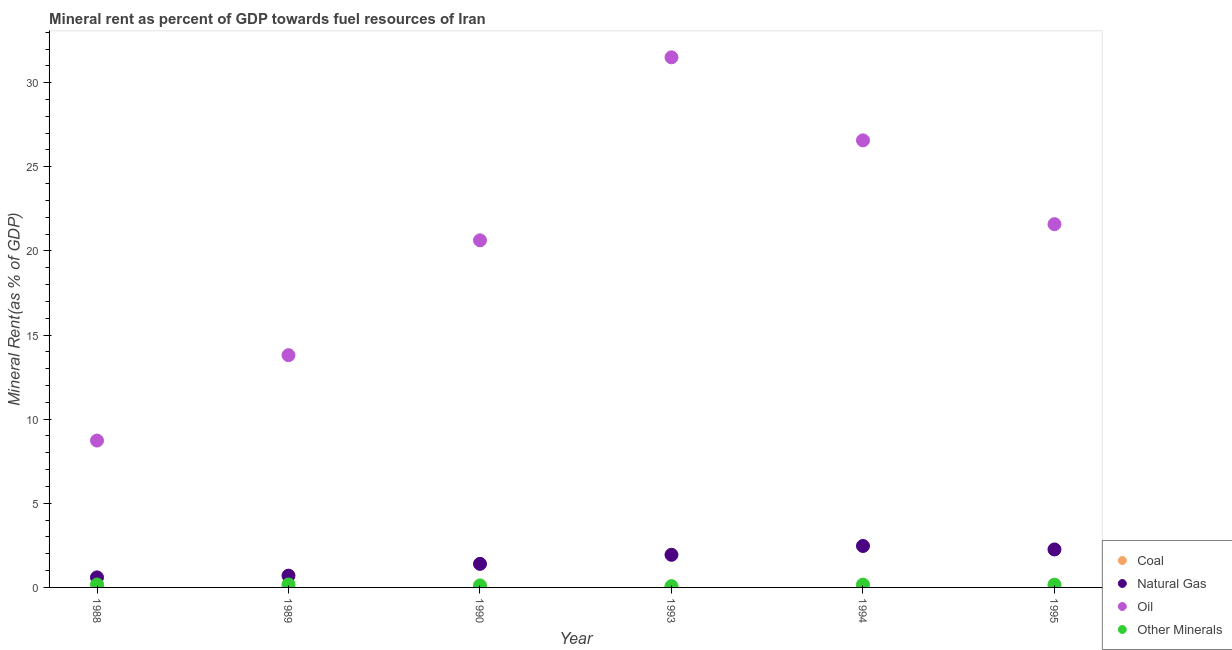How many different coloured dotlines are there?
Your answer should be very brief. 4. What is the coal rent in 1989?
Provide a succinct answer. 0.01. Across all years, what is the maximum coal rent?
Your answer should be compact. 0.01. Across all years, what is the minimum  rent of other minerals?
Your answer should be very brief. 0.08. In which year was the oil rent maximum?
Your response must be concise. 1993. What is the total  rent of other minerals in the graph?
Your response must be concise. 0.88. What is the difference between the oil rent in 1989 and that in 1995?
Your response must be concise. -7.79. What is the difference between the natural gas rent in 1994 and the oil rent in 1988?
Give a very brief answer. -6.27. What is the average natural gas rent per year?
Provide a short and direct response. 1.56. In the year 1995, what is the difference between the natural gas rent and coal rent?
Your response must be concise. 2.25. What is the ratio of the natural gas rent in 1988 to that in 1994?
Provide a succinct answer. 0.24. Is the difference between the natural gas rent in 1989 and 1993 greater than the difference between the oil rent in 1989 and 1993?
Your answer should be compact. Yes. What is the difference between the highest and the second highest  rent of other minerals?
Give a very brief answer. 0. What is the difference between the highest and the lowest  rent of other minerals?
Your answer should be compact. 0.1. Is the sum of the oil rent in 1988 and 1993 greater than the maximum  rent of other minerals across all years?
Keep it short and to the point. Yes. Does the coal rent monotonically increase over the years?
Provide a succinct answer. No. Is the oil rent strictly greater than the  rent of other minerals over the years?
Your response must be concise. Yes. Is the coal rent strictly less than the natural gas rent over the years?
Keep it short and to the point. Yes. What is the difference between two consecutive major ticks on the Y-axis?
Offer a terse response. 5. Are the values on the major ticks of Y-axis written in scientific E-notation?
Keep it short and to the point. No. Does the graph contain any zero values?
Your response must be concise. No. Does the graph contain grids?
Offer a very short reply. No. How are the legend labels stacked?
Give a very brief answer. Vertical. What is the title of the graph?
Offer a very short reply. Mineral rent as percent of GDP towards fuel resources of Iran. What is the label or title of the X-axis?
Keep it short and to the point. Year. What is the label or title of the Y-axis?
Offer a terse response. Mineral Rent(as % of GDP). What is the Mineral Rent(as % of GDP) of Coal in 1988?
Provide a short and direct response. 0.01. What is the Mineral Rent(as % of GDP) in Natural Gas in 1988?
Provide a succinct answer. 0.6. What is the Mineral Rent(as % of GDP) of Oil in 1988?
Offer a terse response. 8.73. What is the Mineral Rent(as % of GDP) in Other Minerals in 1988?
Make the answer very short. 0.17. What is the Mineral Rent(as % of GDP) of Coal in 1989?
Offer a very short reply. 0.01. What is the Mineral Rent(as % of GDP) in Natural Gas in 1989?
Offer a very short reply. 0.7. What is the Mineral Rent(as % of GDP) in Oil in 1989?
Ensure brevity in your answer.  13.8. What is the Mineral Rent(as % of GDP) of Other Minerals in 1989?
Your response must be concise. 0.18. What is the Mineral Rent(as % of GDP) of Coal in 1990?
Your answer should be very brief. 0.01. What is the Mineral Rent(as % of GDP) of Natural Gas in 1990?
Ensure brevity in your answer.  1.4. What is the Mineral Rent(as % of GDP) of Oil in 1990?
Give a very brief answer. 20.63. What is the Mineral Rent(as % of GDP) in Other Minerals in 1990?
Your answer should be very brief. 0.12. What is the Mineral Rent(as % of GDP) in Coal in 1993?
Your response must be concise. 0.01. What is the Mineral Rent(as % of GDP) in Natural Gas in 1993?
Keep it short and to the point. 1.94. What is the Mineral Rent(as % of GDP) of Oil in 1993?
Give a very brief answer. 31.51. What is the Mineral Rent(as % of GDP) in Other Minerals in 1993?
Offer a terse response. 0.08. What is the Mineral Rent(as % of GDP) of Coal in 1994?
Provide a succinct answer. 0.01. What is the Mineral Rent(as % of GDP) of Natural Gas in 1994?
Your answer should be very brief. 2.46. What is the Mineral Rent(as % of GDP) in Oil in 1994?
Your answer should be compact. 26.57. What is the Mineral Rent(as % of GDP) in Other Minerals in 1994?
Ensure brevity in your answer.  0.17. What is the Mineral Rent(as % of GDP) of Coal in 1995?
Your answer should be very brief. 0.01. What is the Mineral Rent(as % of GDP) of Natural Gas in 1995?
Your answer should be compact. 2.26. What is the Mineral Rent(as % of GDP) of Oil in 1995?
Ensure brevity in your answer.  21.59. What is the Mineral Rent(as % of GDP) of Other Minerals in 1995?
Offer a terse response. 0.16. Across all years, what is the maximum Mineral Rent(as % of GDP) of Coal?
Provide a short and direct response. 0.01. Across all years, what is the maximum Mineral Rent(as % of GDP) of Natural Gas?
Provide a short and direct response. 2.46. Across all years, what is the maximum Mineral Rent(as % of GDP) in Oil?
Provide a succinct answer. 31.51. Across all years, what is the maximum Mineral Rent(as % of GDP) of Other Minerals?
Your response must be concise. 0.18. Across all years, what is the minimum Mineral Rent(as % of GDP) in Coal?
Offer a terse response. 0.01. Across all years, what is the minimum Mineral Rent(as % of GDP) in Natural Gas?
Your answer should be very brief. 0.6. Across all years, what is the minimum Mineral Rent(as % of GDP) in Oil?
Provide a short and direct response. 8.73. Across all years, what is the minimum Mineral Rent(as % of GDP) of Other Minerals?
Your response must be concise. 0.08. What is the total Mineral Rent(as % of GDP) in Coal in the graph?
Your answer should be very brief. 0.05. What is the total Mineral Rent(as % of GDP) in Natural Gas in the graph?
Make the answer very short. 9.36. What is the total Mineral Rent(as % of GDP) in Oil in the graph?
Your response must be concise. 122.83. What is the total Mineral Rent(as % of GDP) of Other Minerals in the graph?
Offer a terse response. 0.88. What is the difference between the Mineral Rent(as % of GDP) of Coal in 1988 and that in 1989?
Give a very brief answer. -0. What is the difference between the Mineral Rent(as % of GDP) in Natural Gas in 1988 and that in 1989?
Provide a succinct answer. -0.1. What is the difference between the Mineral Rent(as % of GDP) of Oil in 1988 and that in 1989?
Provide a short and direct response. -5.07. What is the difference between the Mineral Rent(as % of GDP) in Other Minerals in 1988 and that in 1989?
Ensure brevity in your answer.  -0. What is the difference between the Mineral Rent(as % of GDP) in Coal in 1988 and that in 1990?
Offer a very short reply. -0. What is the difference between the Mineral Rent(as % of GDP) in Natural Gas in 1988 and that in 1990?
Offer a terse response. -0.8. What is the difference between the Mineral Rent(as % of GDP) of Oil in 1988 and that in 1990?
Ensure brevity in your answer.  -11.9. What is the difference between the Mineral Rent(as % of GDP) of Other Minerals in 1988 and that in 1990?
Your answer should be compact. 0.06. What is the difference between the Mineral Rent(as % of GDP) in Coal in 1988 and that in 1993?
Give a very brief answer. 0. What is the difference between the Mineral Rent(as % of GDP) in Natural Gas in 1988 and that in 1993?
Offer a terse response. -1.34. What is the difference between the Mineral Rent(as % of GDP) in Oil in 1988 and that in 1993?
Your answer should be very brief. -22.78. What is the difference between the Mineral Rent(as % of GDP) in Other Minerals in 1988 and that in 1993?
Offer a terse response. 0.1. What is the difference between the Mineral Rent(as % of GDP) of Coal in 1988 and that in 1994?
Make the answer very short. -0. What is the difference between the Mineral Rent(as % of GDP) in Natural Gas in 1988 and that in 1994?
Provide a short and direct response. -1.87. What is the difference between the Mineral Rent(as % of GDP) of Oil in 1988 and that in 1994?
Provide a succinct answer. -17.84. What is the difference between the Mineral Rent(as % of GDP) in Other Minerals in 1988 and that in 1994?
Ensure brevity in your answer.  0.01. What is the difference between the Mineral Rent(as % of GDP) of Coal in 1988 and that in 1995?
Provide a succinct answer. -0. What is the difference between the Mineral Rent(as % of GDP) in Natural Gas in 1988 and that in 1995?
Your response must be concise. -1.66. What is the difference between the Mineral Rent(as % of GDP) of Oil in 1988 and that in 1995?
Your answer should be compact. -12.86. What is the difference between the Mineral Rent(as % of GDP) of Other Minerals in 1988 and that in 1995?
Your response must be concise. 0.01. What is the difference between the Mineral Rent(as % of GDP) in Coal in 1989 and that in 1990?
Make the answer very short. -0. What is the difference between the Mineral Rent(as % of GDP) in Natural Gas in 1989 and that in 1990?
Make the answer very short. -0.7. What is the difference between the Mineral Rent(as % of GDP) of Oil in 1989 and that in 1990?
Make the answer very short. -6.83. What is the difference between the Mineral Rent(as % of GDP) of Other Minerals in 1989 and that in 1990?
Keep it short and to the point. 0.06. What is the difference between the Mineral Rent(as % of GDP) of Coal in 1989 and that in 1993?
Your answer should be very brief. 0. What is the difference between the Mineral Rent(as % of GDP) in Natural Gas in 1989 and that in 1993?
Your answer should be compact. -1.24. What is the difference between the Mineral Rent(as % of GDP) in Oil in 1989 and that in 1993?
Offer a very short reply. -17.7. What is the difference between the Mineral Rent(as % of GDP) in Other Minerals in 1989 and that in 1993?
Offer a very short reply. 0.1. What is the difference between the Mineral Rent(as % of GDP) in Coal in 1989 and that in 1994?
Provide a short and direct response. -0. What is the difference between the Mineral Rent(as % of GDP) in Natural Gas in 1989 and that in 1994?
Your answer should be compact. -1.76. What is the difference between the Mineral Rent(as % of GDP) in Oil in 1989 and that in 1994?
Offer a terse response. -12.77. What is the difference between the Mineral Rent(as % of GDP) in Other Minerals in 1989 and that in 1994?
Your response must be concise. 0.01. What is the difference between the Mineral Rent(as % of GDP) of Coal in 1989 and that in 1995?
Keep it short and to the point. -0. What is the difference between the Mineral Rent(as % of GDP) of Natural Gas in 1989 and that in 1995?
Your answer should be compact. -1.56. What is the difference between the Mineral Rent(as % of GDP) in Oil in 1989 and that in 1995?
Keep it short and to the point. -7.79. What is the difference between the Mineral Rent(as % of GDP) of Other Minerals in 1989 and that in 1995?
Give a very brief answer. 0.01. What is the difference between the Mineral Rent(as % of GDP) of Coal in 1990 and that in 1993?
Your answer should be very brief. 0. What is the difference between the Mineral Rent(as % of GDP) in Natural Gas in 1990 and that in 1993?
Keep it short and to the point. -0.54. What is the difference between the Mineral Rent(as % of GDP) in Oil in 1990 and that in 1993?
Offer a terse response. -10.88. What is the difference between the Mineral Rent(as % of GDP) of Other Minerals in 1990 and that in 1993?
Offer a very short reply. 0.04. What is the difference between the Mineral Rent(as % of GDP) of Coal in 1990 and that in 1994?
Keep it short and to the point. -0. What is the difference between the Mineral Rent(as % of GDP) in Natural Gas in 1990 and that in 1994?
Your response must be concise. -1.06. What is the difference between the Mineral Rent(as % of GDP) in Oil in 1990 and that in 1994?
Ensure brevity in your answer.  -5.94. What is the difference between the Mineral Rent(as % of GDP) of Other Minerals in 1990 and that in 1994?
Keep it short and to the point. -0.05. What is the difference between the Mineral Rent(as % of GDP) in Coal in 1990 and that in 1995?
Your answer should be compact. -0. What is the difference between the Mineral Rent(as % of GDP) of Natural Gas in 1990 and that in 1995?
Provide a short and direct response. -0.86. What is the difference between the Mineral Rent(as % of GDP) in Oil in 1990 and that in 1995?
Make the answer very short. -0.96. What is the difference between the Mineral Rent(as % of GDP) of Other Minerals in 1990 and that in 1995?
Offer a very short reply. -0.05. What is the difference between the Mineral Rent(as % of GDP) of Coal in 1993 and that in 1994?
Your answer should be compact. -0. What is the difference between the Mineral Rent(as % of GDP) in Natural Gas in 1993 and that in 1994?
Provide a succinct answer. -0.52. What is the difference between the Mineral Rent(as % of GDP) in Oil in 1993 and that in 1994?
Make the answer very short. 4.94. What is the difference between the Mineral Rent(as % of GDP) of Other Minerals in 1993 and that in 1994?
Your response must be concise. -0.09. What is the difference between the Mineral Rent(as % of GDP) in Coal in 1993 and that in 1995?
Make the answer very short. -0.01. What is the difference between the Mineral Rent(as % of GDP) of Natural Gas in 1993 and that in 1995?
Offer a terse response. -0.32. What is the difference between the Mineral Rent(as % of GDP) in Oil in 1993 and that in 1995?
Provide a succinct answer. 9.92. What is the difference between the Mineral Rent(as % of GDP) of Other Minerals in 1993 and that in 1995?
Offer a very short reply. -0.09. What is the difference between the Mineral Rent(as % of GDP) in Coal in 1994 and that in 1995?
Give a very brief answer. -0. What is the difference between the Mineral Rent(as % of GDP) of Natural Gas in 1994 and that in 1995?
Your answer should be very brief. 0.21. What is the difference between the Mineral Rent(as % of GDP) of Oil in 1994 and that in 1995?
Ensure brevity in your answer.  4.98. What is the difference between the Mineral Rent(as % of GDP) in Other Minerals in 1994 and that in 1995?
Offer a terse response. 0. What is the difference between the Mineral Rent(as % of GDP) in Coal in 1988 and the Mineral Rent(as % of GDP) in Natural Gas in 1989?
Give a very brief answer. -0.69. What is the difference between the Mineral Rent(as % of GDP) in Coal in 1988 and the Mineral Rent(as % of GDP) in Oil in 1989?
Your answer should be compact. -13.8. What is the difference between the Mineral Rent(as % of GDP) of Coal in 1988 and the Mineral Rent(as % of GDP) of Other Minerals in 1989?
Make the answer very short. -0.17. What is the difference between the Mineral Rent(as % of GDP) of Natural Gas in 1988 and the Mineral Rent(as % of GDP) of Oil in 1989?
Offer a very short reply. -13.21. What is the difference between the Mineral Rent(as % of GDP) of Natural Gas in 1988 and the Mineral Rent(as % of GDP) of Other Minerals in 1989?
Provide a succinct answer. 0.42. What is the difference between the Mineral Rent(as % of GDP) in Oil in 1988 and the Mineral Rent(as % of GDP) in Other Minerals in 1989?
Your answer should be very brief. 8.55. What is the difference between the Mineral Rent(as % of GDP) in Coal in 1988 and the Mineral Rent(as % of GDP) in Natural Gas in 1990?
Your answer should be very brief. -1.39. What is the difference between the Mineral Rent(as % of GDP) in Coal in 1988 and the Mineral Rent(as % of GDP) in Oil in 1990?
Keep it short and to the point. -20.62. What is the difference between the Mineral Rent(as % of GDP) in Coal in 1988 and the Mineral Rent(as % of GDP) in Other Minerals in 1990?
Ensure brevity in your answer.  -0.11. What is the difference between the Mineral Rent(as % of GDP) of Natural Gas in 1988 and the Mineral Rent(as % of GDP) of Oil in 1990?
Your answer should be very brief. -20.03. What is the difference between the Mineral Rent(as % of GDP) in Natural Gas in 1988 and the Mineral Rent(as % of GDP) in Other Minerals in 1990?
Your answer should be very brief. 0.48. What is the difference between the Mineral Rent(as % of GDP) of Oil in 1988 and the Mineral Rent(as % of GDP) of Other Minerals in 1990?
Provide a short and direct response. 8.61. What is the difference between the Mineral Rent(as % of GDP) of Coal in 1988 and the Mineral Rent(as % of GDP) of Natural Gas in 1993?
Give a very brief answer. -1.93. What is the difference between the Mineral Rent(as % of GDP) in Coal in 1988 and the Mineral Rent(as % of GDP) in Oil in 1993?
Provide a short and direct response. -31.5. What is the difference between the Mineral Rent(as % of GDP) in Coal in 1988 and the Mineral Rent(as % of GDP) in Other Minerals in 1993?
Offer a very short reply. -0.07. What is the difference between the Mineral Rent(as % of GDP) of Natural Gas in 1988 and the Mineral Rent(as % of GDP) of Oil in 1993?
Your answer should be compact. -30.91. What is the difference between the Mineral Rent(as % of GDP) of Natural Gas in 1988 and the Mineral Rent(as % of GDP) of Other Minerals in 1993?
Provide a short and direct response. 0.52. What is the difference between the Mineral Rent(as % of GDP) of Oil in 1988 and the Mineral Rent(as % of GDP) of Other Minerals in 1993?
Offer a terse response. 8.65. What is the difference between the Mineral Rent(as % of GDP) of Coal in 1988 and the Mineral Rent(as % of GDP) of Natural Gas in 1994?
Provide a short and direct response. -2.46. What is the difference between the Mineral Rent(as % of GDP) in Coal in 1988 and the Mineral Rent(as % of GDP) in Oil in 1994?
Keep it short and to the point. -26.56. What is the difference between the Mineral Rent(as % of GDP) in Coal in 1988 and the Mineral Rent(as % of GDP) in Other Minerals in 1994?
Your answer should be compact. -0.16. What is the difference between the Mineral Rent(as % of GDP) of Natural Gas in 1988 and the Mineral Rent(as % of GDP) of Oil in 1994?
Give a very brief answer. -25.97. What is the difference between the Mineral Rent(as % of GDP) in Natural Gas in 1988 and the Mineral Rent(as % of GDP) in Other Minerals in 1994?
Provide a short and direct response. 0.43. What is the difference between the Mineral Rent(as % of GDP) of Oil in 1988 and the Mineral Rent(as % of GDP) of Other Minerals in 1994?
Your answer should be very brief. 8.56. What is the difference between the Mineral Rent(as % of GDP) in Coal in 1988 and the Mineral Rent(as % of GDP) in Natural Gas in 1995?
Your response must be concise. -2.25. What is the difference between the Mineral Rent(as % of GDP) of Coal in 1988 and the Mineral Rent(as % of GDP) of Oil in 1995?
Your answer should be compact. -21.58. What is the difference between the Mineral Rent(as % of GDP) in Coal in 1988 and the Mineral Rent(as % of GDP) in Other Minerals in 1995?
Give a very brief answer. -0.16. What is the difference between the Mineral Rent(as % of GDP) in Natural Gas in 1988 and the Mineral Rent(as % of GDP) in Oil in 1995?
Your answer should be compact. -20.99. What is the difference between the Mineral Rent(as % of GDP) of Natural Gas in 1988 and the Mineral Rent(as % of GDP) of Other Minerals in 1995?
Provide a succinct answer. 0.43. What is the difference between the Mineral Rent(as % of GDP) of Oil in 1988 and the Mineral Rent(as % of GDP) of Other Minerals in 1995?
Your response must be concise. 8.57. What is the difference between the Mineral Rent(as % of GDP) in Coal in 1989 and the Mineral Rent(as % of GDP) in Natural Gas in 1990?
Make the answer very short. -1.39. What is the difference between the Mineral Rent(as % of GDP) of Coal in 1989 and the Mineral Rent(as % of GDP) of Oil in 1990?
Offer a very short reply. -20.62. What is the difference between the Mineral Rent(as % of GDP) of Coal in 1989 and the Mineral Rent(as % of GDP) of Other Minerals in 1990?
Your answer should be very brief. -0.11. What is the difference between the Mineral Rent(as % of GDP) in Natural Gas in 1989 and the Mineral Rent(as % of GDP) in Oil in 1990?
Your answer should be very brief. -19.93. What is the difference between the Mineral Rent(as % of GDP) in Natural Gas in 1989 and the Mineral Rent(as % of GDP) in Other Minerals in 1990?
Your answer should be very brief. 0.58. What is the difference between the Mineral Rent(as % of GDP) of Oil in 1989 and the Mineral Rent(as % of GDP) of Other Minerals in 1990?
Your answer should be very brief. 13.69. What is the difference between the Mineral Rent(as % of GDP) of Coal in 1989 and the Mineral Rent(as % of GDP) of Natural Gas in 1993?
Offer a very short reply. -1.93. What is the difference between the Mineral Rent(as % of GDP) in Coal in 1989 and the Mineral Rent(as % of GDP) in Oil in 1993?
Your response must be concise. -31.5. What is the difference between the Mineral Rent(as % of GDP) in Coal in 1989 and the Mineral Rent(as % of GDP) in Other Minerals in 1993?
Keep it short and to the point. -0.07. What is the difference between the Mineral Rent(as % of GDP) of Natural Gas in 1989 and the Mineral Rent(as % of GDP) of Oil in 1993?
Make the answer very short. -30.81. What is the difference between the Mineral Rent(as % of GDP) in Natural Gas in 1989 and the Mineral Rent(as % of GDP) in Other Minerals in 1993?
Keep it short and to the point. 0.62. What is the difference between the Mineral Rent(as % of GDP) of Oil in 1989 and the Mineral Rent(as % of GDP) of Other Minerals in 1993?
Keep it short and to the point. 13.73. What is the difference between the Mineral Rent(as % of GDP) of Coal in 1989 and the Mineral Rent(as % of GDP) of Natural Gas in 1994?
Give a very brief answer. -2.46. What is the difference between the Mineral Rent(as % of GDP) of Coal in 1989 and the Mineral Rent(as % of GDP) of Oil in 1994?
Offer a very short reply. -26.56. What is the difference between the Mineral Rent(as % of GDP) in Coal in 1989 and the Mineral Rent(as % of GDP) in Other Minerals in 1994?
Your answer should be very brief. -0.16. What is the difference between the Mineral Rent(as % of GDP) in Natural Gas in 1989 and the Mineral Rent(as % of GDP) in Oil in 1994?
Your response must be concise. -25.87. What is the difference between the Mineral Rent(as % of GDP) of Natural Gas in 1989 and the Mineral Rent(as % of GDP) of Other Minerals in 1994?
Provide a succinct answer. 0.53. What is the difference between the Mineral Rent(as % of GDP) of Oil in 1989 and the Mineral Rent(as % of GDP) of Other Minerals in 1994?
Offer a terse response. 13.64. What is the difference between the Mineral Rent(as % of GDP) of Coal in 1989 and the Mineral Rent(as % of GDP) of Natural Gas in 1995?
Make the answer very short. -2.25. What is the difference between the Mineral Rent(as % of GDP) of Coal in 1989 and the Mineral Rent(as % of GDP) of Oil in 1995?
Keep it short and to the point. -21.58. What is the difference between the Mineral Rent(as % of GDP) in Coal in 1989 and the Mineral Rent(as % of GDP) in Other Minerals in 1995?
Your answer should be compact. -0.16. What is the difference between the Mineral Rent(as % of GDP) in Natural Gas in 1989 and the Mineral Rent(as % of GDP) in Oil in 1995?
Your answer should be compact. -20.89. What is the difference between the Mineral Rent(as % of GDP) of Natural Gas in 1989 and the Mineral Rent(as % of GDP) of Other Minerals in 1995?
Your response must be concise. 0.54. What is the difference between the Mineral Rent(as % of GDP) of Oil in 1989 and the Mineral Rent(as % of GDP) of Other Minerals in 1995?
Offer a terse response. 13.64. What is the difference between the Mineral Rent(as % of GDP) of Coal in 1990 and the Mineral Rent(as % of GDP) of Natural Gas in 1993?
Your answer should be compact. -1.93. What is the difference between the Mineral Rent(as % of GDP) of Coal in 1990 and the Mineral Rent(as % of GDP) of Oil in 1993?
Keep it short and to the point. -31.5. What is the difference between the Mineral Rent(as % of GDP) in Coal in 1990 and the Mineral Rent(as % of GDP) in Other Minerals in 1993?
Your response must be concise. -0.07. What is the difference between the Mineral Rent(as % of GDP) in Natural Gas in 1990 and the Mineral Rent(as % of GDP) in Oil in 1993?
Offer a very short reply. -30.11. What is the difference between the Mineral Rent(as % of GDP) in Natural Gas in 1990 and the Mineral Rent(as % of GDP) in Other Minerals in 1993?
Offer a terse response. 1.32. What is the difference between the Mineral Rent(as % of GDP) in Oil in 1990 and the Mineral Rent(as % of GDP) in Other Minerals in 1993?
Your answer should be compact. 20.55. What is the difference between the Mineral Rent(as % of GDP) of Coal in 1990 and the Mineral Rent(as % of GDP) of Natural Gas in 1994?
Your response must be concise. -2.46. What is the difference between the Mineral Rent(as % of GDP) of Coal in 1990 and the Mineral Rent(as % of GDP) of Oil in 1994?
Make the answer very short. -26.56. What is the difference between the Mineral Rent(as % of GDP) in Coal in 1990 and the Mineral Rent(as % of GDP) in Other Minerals in 1994?
Your answer should be very brief. -0.16. What is the difference between the Mineral Rent(as % of GDP) of Natural Gas in 1990 and the Mineral Rent(as % of GDP) of Oil in 1994?
Ensure brevity in your answer.  -25.17. What is the difference between the Mineral Rent(as % of GDP) of Natural Gas in 1990 and the Mineral Rent(as % of GDP) of Other Minerals in 1994?
Make the answer very short. 1.23. What is the difference between the Mineral Rent(as % of GDP) of Oil in 1990 and the Mineral Rent(as % of GDP) of Other Minerals in 1994?
Offer a very short reply. 20.46. What is the difference between the Mineral Rent(as % of GDP) in Coal in 1990 and the Mineral Rent(as % of GDP) in Natural Gas in 1995?
Give a very brief answer. -2.25. What is the difference between the Mineral Rent(as % of GDP) of Coal in 1990 and the Mineral Rent(as % of GDP) of Oil in 1995?
Give a very brief answer. -21.58. What is the difference between the Mineral Rent(as % of GDP) in Coal in 1990 and the Mineral Rent(as % of GDP) in Other Minerals in 1995?
Provide a short and direct response. -0.16. What is the difference between the Mineral Rent(as % of GDP) of Natural Gas in 1990 and the Mineral Rent(as % of GDP) of Oil in 1995?
Offer a very short reply. -20.19. What is the difference between the Mineral Rent(as % of GDP) of Natural Gas in 1990 and the Mineral Rent(as % of GDP) of Other Minerals in 1995?
Offer a very short reply. 1.24. What is the difference between the Mineral Rent(as % of GDP) of Oil in 1990 and the Mineral Rent(as % of GDP) of Other Minerals in 1995?
Ensure brevity in your answer.  20.47. What is the difference between the Mineral Rent(as % of GDP) of Coal in 1993 and the Mineral Rent(as % of GDP) of Natural Gas in 1994?
Give a very brief answer. -2.46. What is the difference between the Mineral Rent(as % of GDP) of Coal in 1993 and the Mineral Rent(as % of GDP) of Oil in 1994?
Provide a short and direct response. -26.56. What is the difference between the Mineral Rent(as % of GDP) of Coal in 1993 and the Mineral Rent(as % of GDP) of Other Minerals in 1994?
Give a very brief answer. -0.16. What is the difference between the Mineral Rent(as % of GDP) of Natural Gas in 1993 and the Mineral Rent(as % of GDP) of Oil in 1994?
Offer a very short reply. -24.63. What is the difference between the Mineral Rent(as % of GDP) of Natural Gas in 1993 and the Mineral Rent(as % of GDP) of Other Minerals in 1994?
Offer a terse response. 1.77. What is the difference between the Mineral Rent(as % of GDP) of Oil in 1993 and the Mineral Rent(as % of GDP) of Other Minerals in 1994?
Keep it short and to the point. 31.34. What is the difference between the Mineral Rent(as % of GDP) of Coal in 1993 and the Mineral Rent(as % of GDP) of Natural Gas in 1995?
Your response must be concise. -2.25. What is the difference between the Mineral Rent(as % of GDP) of Coal in 1993 and the Mineral Rent(as % of GDP) of Oil in 1995?
Provide a short and direct response. -21.58. What is the difference between the Mineral Rent(as % of GDP) of Coal in 1993 and the Mineral Rent(as % of GDP) of Other Minerals in 1995?
Your answer should be compact. -0.16. What is the difference between the Mineral Rent(as % of GDP) of Natural Gas in 1993 and the Mineral Rent(as % of GDP) of Oil in 1995?
Give a very brief answer. -19.65. What is the difference between the Mineral Rent(as % of GDP) in Natural Gas in 1993 and the Mineral Rent(as % of GDP) in Other Minerals in 1995?
Provide a short and direct response. 1.78. What is the difference between the Mineral Rent(as % of GDP) in Oil in 1993 and the Mineral Rent(as % of GDP) in Other Minerals in 1995?
Offer a very short reply. 31.34. What is the difference between the Mineral Rent(as % of GDP) in Coal in 1994 and the Mineral Rent(as % of GDP) in Natural Gas in 1995?
Provide a short and direct response. -2.25. What is the difference between the Mineral Rent(as % of GDP) of Coal in 1994 and the Mineral Rent(as % of GDP) of Oil in 1995?
Your answer should be very brief. -21.58. What is the difference between the Mineral Rent(as % of GDP) in Coal in 1994 and the Mineral Rent(as % of GDP) in Other Minerals in 1995?
Your answer should be very brief. -0.16. What is the difference between the Mineral Rent(as % of GDP) in Natural Gas in 1994 and the Mineral Rent(as % of GDP) in Oil in 1995?
Provide a short and direct response. -19.13. What is the difference between the Mineral Rent(as % of GDP) in Natural Gas in 1994 and the Mineral Rent(as % of GDP) in Other Minerals in 1995?
Give a very brief answer. 2.3. What is the difference between the Mineral Rent(as % of GDP) of Oil in 1994 and the Mineral Rent(as % of GDP) of Other Minerals in 1995?
Provide a succinct answer. 26.41. What is the average Mineral Rent(as % of GDP) of Coal per year?
Your answer should be very brief. 0.01. What is the average Mineral Rent(as % of GDP) of Natural Gas per year?
Provide a short and direct response. 1.56. What is the average Mineral Rent(as % of GDP) of Oil per year?
Ensure brevity in your answer.  20.47. What is the average Mineral Rent(as % of GDP) in Other Minerals per year?
Offer a terse response. 0.15. In the year 1988, what is the difference between the Mineral Rent(as % of GDP) of Coal and Mineral Rent(as % of GDP) of Natural Gas?
Your answer should be compact. -0.59. In the year 1988, what is the difference between the Mineral Rent(as % of GDP) in Coal and Mineral Rent(as % of GDP) in Oil?
Provide a succinct answer. -8.72. In the year 1988, what is the difference between the Mineral Rent(as % of GDP) of Coal and Mineral Rent(as % of GDP) of Other Minerals?
Make the answer very short. -0.17. In the year 1988, what is the difference between the Mineral Rent(as % of GDP) of Natural Gas and Mineral Rent(as % of GDP) of Oil?
Your answer should be very brief. -8.13. In the year 1988, what is the difference between the Mineral Rent(as % of GDP) in Natural Gas and Mineral Rent(as % of GDP) in Other Minerals?
Your response must be concise. 0.42. In the year 1988, what is the difference between the Mineral Rent(as % of GDP) of Oil and Mineral Rent(as % of GDP) of Other Minerals?
Your answer should be compact. 8.55. In the year 1989, what is the difference between the Mineral Rent(as % of GDP) in Coal and Mineral Rent(as % of GDP) in Natural Gas?
Provide a succinct answer. -0.69. In the year 1989, what is the difference between the Mineral Rent(as % of GDP) of Coal and Mineral Rent(as % of GDP) of Oil?
Provide a succinct answer. -13.8. In the year 1989, what is the difference between the Mineral Rent(as % of GDP) of Coal and Mineral Rent(as % of GDP) of Other Minerals?
Give a very brief answer. -0.17. In the year 1989, what is the difference between the Mineral Rent(as % of GDP) in Natural Gas and Mineral Rent(as % of GDP) in Oil?
Your answer should be compact. -13.1. In the year 1989, what is the difference between the Mineral Rent(as % of GDP) in Natural Gas and Mineral Rent(as % of GDP) in Other Minerals?
Provide a short and direct response. 0.52. In the year 1989, what is the difference between the Mineral Rent(as % of GDP) in Oil and Mineral Rent(as % of GDP) in Other Minerals?
Give a very brief answer. 13.63. In the year 1990, what is the difference between the Mineral Rent(as % of GDP) of Coal and Mineral Rent(as % of GDP) of Natural Gas?
Your response must be concise. -1.39. In the year 1990, what is the difference between the Mineral Rent(as % of GDP) of Coal and Mineral Rent(as % of GDP) of Oil?
Give a very brief answer. -20.62. In the year 1990, what is the difference between the Mineral Rent(as % of GDP) of Coal and Mineral Rent(as % of GDP) of Other Minerals?
Ensure brevity in your answer.  -0.11. In the year 1990, what is the difference between the Mineral Rent(as % of GDP) of Natural Gas and Mineral Rent(as % of GDP) of Oil?
Your answer should be very brief. -19.23. In the year 1990, what is the difference between the Mineral Rent(as % of GDP) in Natural Gas and Mineral Rent(as % of GDP) in Other Minerals?
Your answer should be compact. 1.28. In the year 1990, what is the difference between the Mineral Rent(as % of GDP) in Oil and Mineral Rent(as % of GDP) in Other Minerals?
Offer a terse response. 20.51. In the year 1993, what is the difference between the Mineral Rent(as % of GDP) of Coal and Mineral Rent(as % of GDP) of Natural Gas?
Offer a very short reply. -1.93. In the year 1993, what is the difference between the Mineral Rent(as % of GDP) in Coal and Mineral Rent(as % of GDP) in Oil?
Make the answer very short. -31.5. In the year 1993, what is the difference between the Mineral Rent(as % of GDP) of Coal and Mineral Rent(as % of GDP) of Other Minerals?
Offer a very short reply. -0.07. In the year 1993, what is the difference between the Mineral Rent(as % of GDP) of Natural Gas and Mineral Rent(as % of GDP) of Oil?
Give a very brief answer. -29.57. In the year 1993, what is the difference between the Mineral Rent(as % of GDP) in Natural Gas and Mineral Rent(as % of GDP) in Other Minerals?
Your answer should be compact. 1.86. In the year 1993, what is the difference between the Mineral Rent(as % of GDP) in Oil and Mineral Rent(as % of GDP) in Other Minerals?
Ensure brevity in your answer.  31.43. In the year 1994, what is the difference between the Mineral Rent(as % of GDP) of Coal and Mineral Rent(as % of GDP) of Natural Gas?
Give a very brief answer. -2.46. In the year 1994, what is the difference between the Mineral Rent(as % of GDP) in Coal and Mineral Rent(as % of GDP) in Oil?
Ensure brevity in your answer.  -26.56. In the year 1994, what is the difference between the Mineral Rent(as % of GDP) in Coal and Mineral Rent(as % of GDP) in Other Minerals?
Your answer should be very brief. -0.16. In the year 1994, what is the difference between the Mineral Rent(as % of GDP) of Natural Gas and Mineral Rent(as % of GDP) of Oil?
Provide a short and direct response. -24.11. In the year 1994, what is the difference between the Mineral Rent(as % of GDP) in Natural Gas and Mineral Rent(as % of GDP) in Other Minerals?
Your response must be concise. 2.29. In the year 1994, what is the difference between the Mineral Rent(as % of GDP) in Oil and Mineral Rent(as % of GDP) in Other Minerals?
Offer a terse response. 26.4. In the year 1995, what is the difference between the Mineral Rent(as % of GDP) in Coal and Mineral Rent(as % of GDP) in Natural Gas?
Give a very brief answer. -2.25. In the year 1995, what is the difference between the Mineral Rent(as % of GDP) in Coal and Mineral Rent(as % of GDP) in Oil?
Provide a succinct answer. -21.58. In the year 1995, what is the difference between the Mineral Rent(as % of GDP) of Coal and Mineral Rent(as % of GDP) of Other Minerals?
Offer a terse response. -0.15. In the year 1995, what is the difference between the Mineral Rent(as % of GDP) of Natural Gas and Mineral Rent(as % of GDP) of Oil?
Offer a terse response. -19.33. In the year 1995, what is the difference between the Mineral Rent(as % of GDP) in Natural Gas and Mineral Rent(as % of GDP) in Other Minerals?
Your response must be concise. 2.09. In the year 1995, what is the difference between the Mineral Rent(as % of GDP) in Oil and Mineral Rent(as % of GDP) in Other Minerals?
Give a very brief answer. 21.43. What is the ratio of the Mineral Rent(as % of GDP) in Coal in 1988 to that in 1989?
Your answer should be very brief. 0.9. What is the ratio of the Mineral Rent(as % of GDP) in Natural Gas in 1988 to that in 1989?
Provide a succinct answer. 0.85. What is the ratio of the Mineral Rent(as % of GDP) of Oil in 1988 to that in 1989?
Your answer should be very brief. 0.63. What is the ratio of the Mineral Rent(as % of GDP) in Coal in 1988 to that in 1990?
Provide a succinct answer. 0.87. What is the ratio of the Mineral Rent(as % of GDP) in Natural Gas in 1988 to that in 1990?
Make the answer very short. 0.43. What is the ratio of the Mineral Rent(as % of GDP) in Oil in 1988 to that in 1990?
Provide a short and direct response. 0.42. What is the ratio of the Mineral Rent(as % of GDP) of Other Minerals in 1988 to that in 1990?
Your answer should be compact. 1.47. What is the ratio of the Mineral Rent(as % of GDP) in Coal in 1988 to that in 1993?
Give a very brief answer. 1.36. What is the ratio of the Mineral Rent(as % of GDP) in Natural Gas in 1988 to that in 1993?
Your answer should be very brief. 0.31. What is the ratio of the Mineral Rent(as % of GDP) in Oil in 1988 to that in 1993?
Ensure brevity in your answer.  0.28. What is the ratio of the Mineral Rent(as % of GDP) of Other Minerals in 1988 to that in 1993?
Your response must be concise. 2.28. What is the ratio of the Mineral Rent(as % of GDP) of Coal in 1988 to that in 1994?
Offer a terse response. 0.87. What is the ratio of the Mineral Rent(as % of GDP) in Natural Gas in 1988 to that in 1994?
Offer a very short reply. 0.24. What is the ratio of the Mineral Rent(as % of GDP) in Oil in 1988 to that in 1994?
Make the answer very short. 0.33. What is the ratio of the Mineral Rent(as % of GDP) of Other Minerals in 1988 to that in 1994?
Make the answer very short. 1.04. What is the ratio of the Mineral Rent(as % of GDP) of Coal in 1988 to that in 1995?
Make the answer very short. 0.63. What is the ratio of the Mineral Rent(as % of GDP) of Natural Gas in 1988 to that in 1995?
Keep it short and to the point. 0.26. What is the ratio of the Mineral Rent(as % of GDP) of Oil in 1988 to that in 1995?
Your answer should be very brief. 0.4. What is the ratio of the Mineral Rent(as % of GDP) of Other Minerals in 1988 to that in 1995?
Keep it short and to the point. 1.07. What is the ratio of the Mineral Rent(as % of GDP) of Coal in 1989 to that in 1990?
Your response must be concise. 0.97. What is the ratio of the Mineral Rent(as % of GDP) in Natural Gas in 1989 to that in 1990?
Offer a very short reply. 0.5. What is the ratio of the Mineral Rent(as % of GDP) of Oil in 1989 to that in 1990?
Provide a short and direct response. 0.67. What is the ratio of the Mineral Rent(as % of GDP) of Other Minerals in 1989 to that in 1990?
Keep it short and to the point. 1.48. What is the ratio of the Mineral Rent(as % of GDP) of Coal in 1989 to that in 1993?
Keep it short and to the point. 1.51. What is the ratio of the Mineral Rent(as % of GDP) in Natural Gas in 1989 to that in 1993?
Give a very brief answer. 0.36. What is the ratio of the Mineral Rent(as % of GDP) of Oil in 1989 to that in 1993?
Provide a short and direct response. 0.44. What is the ratio of the Mineral Rent(as % of GDP) in Other Minerals in 1989 to that in 1993?
Your answer should be compact. 2.3. What is the ratio of the Mineral Rent(as % of GDP) in Coal in 1989 to that in 1994?
Offer a terse response. 0.96. What is the ratio of the Mineral Rent(as % of GDP) of Natural Gas in 1989 to that in 1994?
Your answer should be compact. 0.28. What is the ratio of the Mineral Rent(as % of GDP) of Oil in 1989 to that in 1994?
Provide a succinct answer. 0.52. What is the ratio of the Mineral Rent(as % of GDP) in Other Minerals in 1989 to that in 1994?
Provide a succinct answer. 1.05. What is the ratio of the Mineral Rent(as % of GDP) of Coal in 1989 to that in 1995?
Your answer should be very brief. 0.7. What is the ratio of the Mineral Rent(as % of GDP) of Natural Gas in 1989 to that in 1995?
Provide a succinct answer. 0.31. What is the ratio of the Mineral Rent(as % of GDP) in Oil in 1989 to that in 1995?
Offer a terse response. 0.64. What is the ratio of the Mineral Rent(as % of GDP) in Other Minerals in 1989 to that in 1995?
Give a very brief answer. 1.08. What is the ratio of the Mineral Rent(as % of GDP) of Coal in 1990 to that in 1993?
Your answer should be compact. 1.56. What is the ratio of the Mineral Rent(as % of GDP) of Natural Gas in 1990 to that in 1993?
Ensure brevity in your answer.  0.72. What is the ratio of the Mineral Rent(as % of GDP) in Oil in 1990 to that in 1993?
Your response must be concise. 0.65. What is the ratio of the Mineral Rent(as % of GDP) in Other Minerals in 1990 to that in 1993?
Your answer should be compact. 1.55. What is the ratio of the Mineral Rent(as % of GDP) of Coal in 1990 to that in 1994?
Ensure brevity in your answer.  1. What is the ratio of the Mineral Rent(as % of GDP) in Natural Gas in 1990 to that in 1994?
Provide a succinct answer. 0.57. What is the ratio of the Mineral Rent(as % of GDP) in Oil in 1990 to that in 1994?
Keep it short and to the point. 0.78. What is the ratio of the Mineral Rent(as % of GDP) in Other Minerals in 1990 to that in 1994?
Keep it short and to the point. 0.71. What is the ratio of the Mineral Rent(as % of GDP) in Coal in 1990 to that in 1995?
Provide a succinct answer. 0.72. What is the ratio of the Mineral Rent(as % of GDP) in Natural Gas in 1990 to that in 1995?
Offer a very short reply. 0.62. What is the ratio of the Mineral Rent(as % of GDP) of Oil in 1990 to that in 1995?
Ensure brevity in your answer.  0.96. What is the ratio of the Mineral Rent(as % of GDP) in Other Minerals in 1990 to that in 1995?
Offer a terse response. 0.72. What is the ratio of the Mineral Rent(as % of GDP) of Coal in 1993 to that in 1994?
Your answer should be very brief. 0.64. What is the ratio of the Mineral Rent(as % of GDP) in Natural Gas in 1993 to that in 1994?
Provide a succinct answer. 0.79. What is the ratio of the Mineral Rent(as % of GDP) in Oil in 1993 to that in 1994?
Offer a terse response. 1.19. What is the ratio of the Mineral Rent(as % of GDP) in Other Minerals in 1993 to that in 1994?
Keep it short and to the point. 0.46. What is the ratio of the Mineral Rent(as % of GDP) of Coal in 1993 to that in 1995?
Provide a short and direct response. 0.46. What is the ratio of the Mineral Rent(as % of GDP) in Natural Gas in 1993 to that in 1995?
Provide a succinct answer. 0.86. What is the ratio of the Mineral Rent(as % of GDP) of Oil in 1993 to that in 1995?
Your response must be concise. 1.46. What is the ratio of the Mineral Rent(as % of GDP) of Other Minerals in 1993 to that in 1995?
Your response must be concise. 0.47. What is the ratio of the Mineral Rent(as % of GDP) of Coal in 1994 to that in 1995?
Your answer should be compact. 0.73. What is the ratio of the Mineral Rent(as % of GDP) in Natural Gas in 1994 to that in 1995?
Your response must be concise. 1.09. What is the ratio of the Mineral Rent(as % of GDP) of Oil in 1994 to that in 1995?
Ensure brevity in your answer.  1.23. What is the ratio of the Mineral Rent(as % of GDP) in Other Minerals in 1994 to that in 1995?
Your answer should be very brief. 1.03. What is the difference between the highest and the second highest Mineral Rent(as % of GDP) in Coal?
Give a very brief answer. 0. What is the difference between the highest and the second highest Mineral Rent(as % of GDP) of Natural Gas?
Ensure brevity in your answer.  0.21. What is the difference between the highest and the second highest Mineral Rent(as % of GDP) in Oil?
Keep it short and to the point. 4.94. What is the difference between the highest and the second highest Mineral Rent(as % of GDP) in Other Minerals?
Make the answer very short. 0. What is the difference between the highest and the lowest Mineral Rent(as % of GDP) in Coal?
Ensure brevity in your answer.  0.01. What is the difference between the highest and the lowest Mineral Rent(as % of GDP) in Natural Gas?
Give a very brief answer. 1.87. What is the difference between the highest and the lowest Mineral Rent(as % of GDP) in Oil?
Your answer should be compact. 22.78. What is the difference between the highest and the lowest Mineral Rent(as % of GDP) of Other Minerals?
Your answer should be very brief. 0.1. 